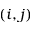Convert formula to latex. <formula><loc_0><loc_0><loc_500><loc_500>( i , j )</formula> 